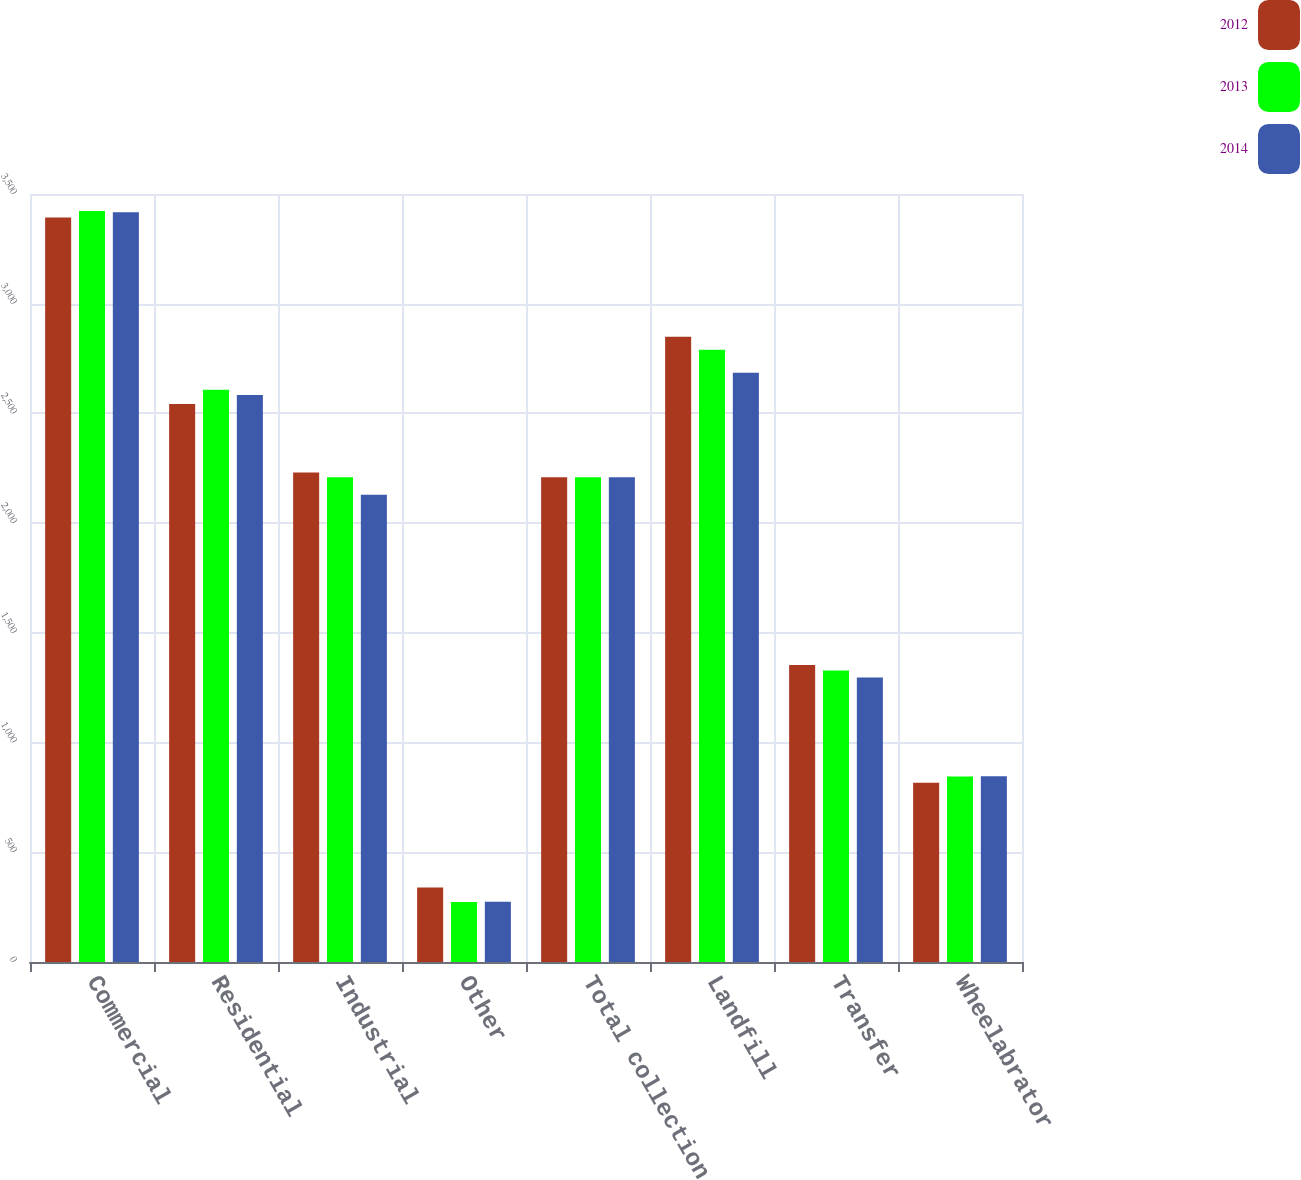Convert chart to OTSL. <chart><loc_0><loc_0><loc_500><loc_500><stacked_bar_chart><ecel><fcel>Commercial<fcel>Residential<fcel>Industrial<fcel>Other<fcel>Total collection<fcel>Landfill<fcel>Transfer<fcel>Wheelabrator<nl><fcel>2012<fcel>3393<fcel>2543<fcel>2231<fcel>340<fcel>2209<fcel>2849<fcel>1353<fcel>817<nl><fcel>2013<fcel>3423<fcel>2608<fcel>2209<fcel>273<fcel>2209<fcel>2790<fcel>1329<fcel>845<nl><fcel>2014<fcel>3417<fcel>2584<fcel>2129<fcel>275<fcel>2209<fcel>2685<fcel>1296<fcel>846<nl></chart> 